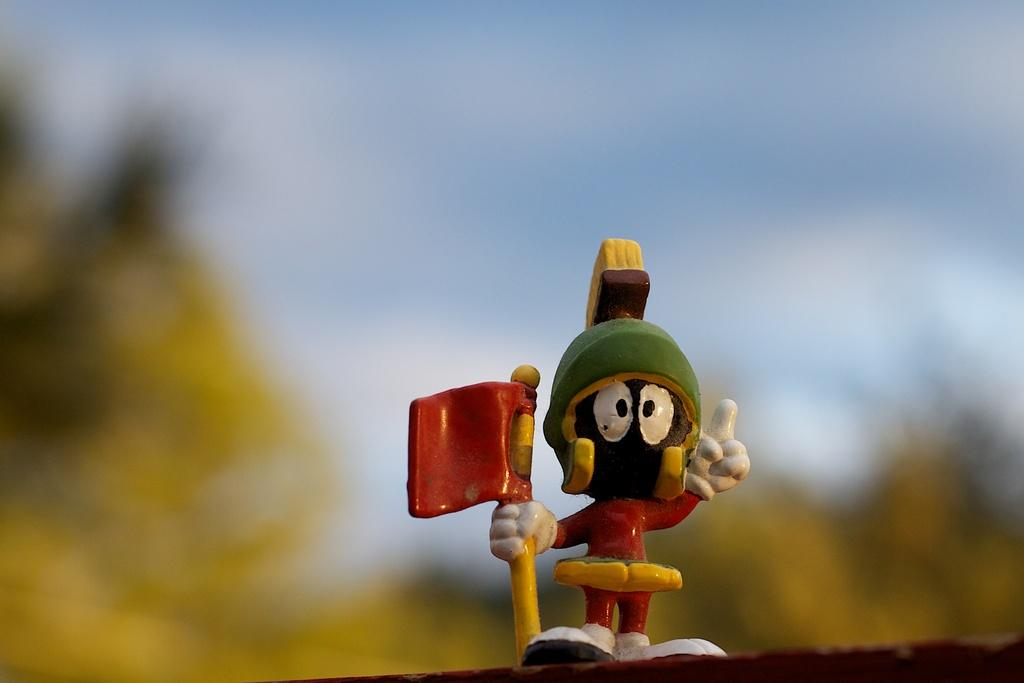What object can be seen in the image? There is a toy in the image. Can you describe the background of the image? The background of the image is blurred. What type of poison is present in the image? There is no poison present in the image; it features a toy and a blurred background. 